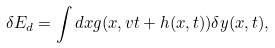Convert formula to latex. <formula><loc_0><loc_0><loc_500><loc_500>\delta E _ { d } = \int d x g ( x , v t + h ( x , t ) ) \delta y ( x , t ) ,</formula> 